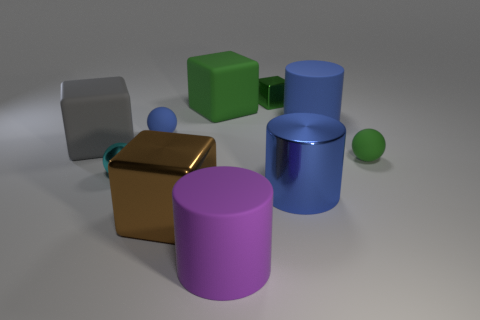What number of other objects are the same size as the green metal thing?
Provide a short and direct response. 3. There is a ball to the right of the small blue thing; what material is it?
Provide a short and direct response. Rubber. Do the big purple matte object and the green metal thing have the same shape?
Offer a very short reply. No. There is a shiny cube in front of the large rubber thing to the left of the small metal object left of the large purple cylinder; what is its color?
Give a very brief answer. Brown. How many large green rubber objects have the same shape as the blue shiny thing?
Provide a succinct answer. 0. There is a blue rubber object on the left side of the matte thing in front of the tiny green rubber object; what size is it?
Give a very brief answer. Small. Do the blue metallic cylinder and the gray rubber block have the same size?
Your response must be concise. Yes. There is a tiny matte object that is left of the big rubber cylinder that is in front of the brown object; are there any big gray things that are on the left side of it?
Give a very brief answer. Yes. What size is the green shiny cube?
Keep it short and to the point. Small. How many other blue metallic cylinders have the same size as the metal cylinder?
Ensure brevity in your answer.  0. 